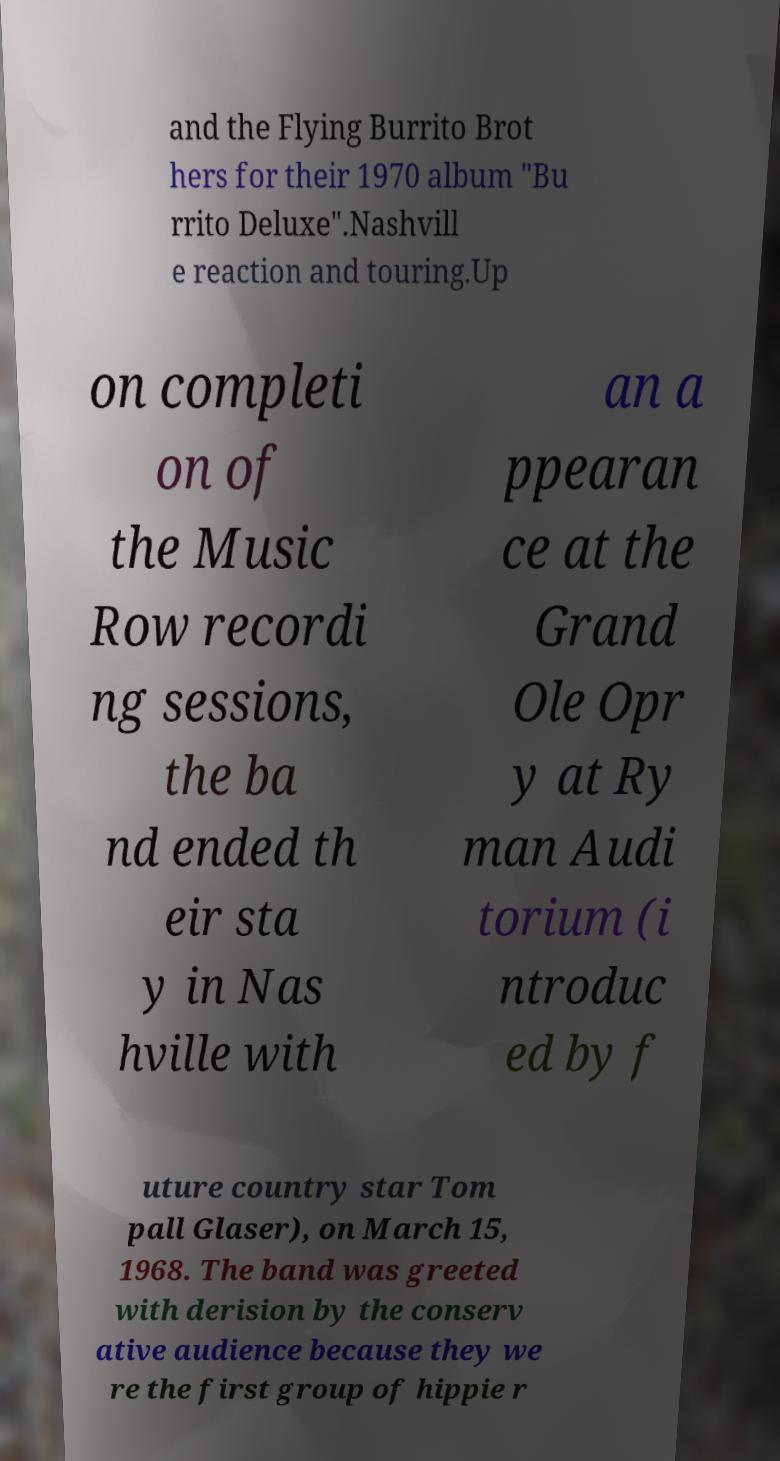Please identify and transcribe the text found in this image. and the Flying Burrito Brot hers for their 1970 album "Bu rrito Deluxe".Nashvill e reaction and touring.Up on completi on of the Music Row recordi ng sessions, the ba nd ended th eir sta y in Nas hville with an a ppearan ce at the Grand Ole Opr y at Ry man Audi torium (i ntroduc ed by f uture country star Tom pall Glaser), on March 15, 1968. The band was greeted with derision by the conserv ative audience because they we re the first group of hippie r 